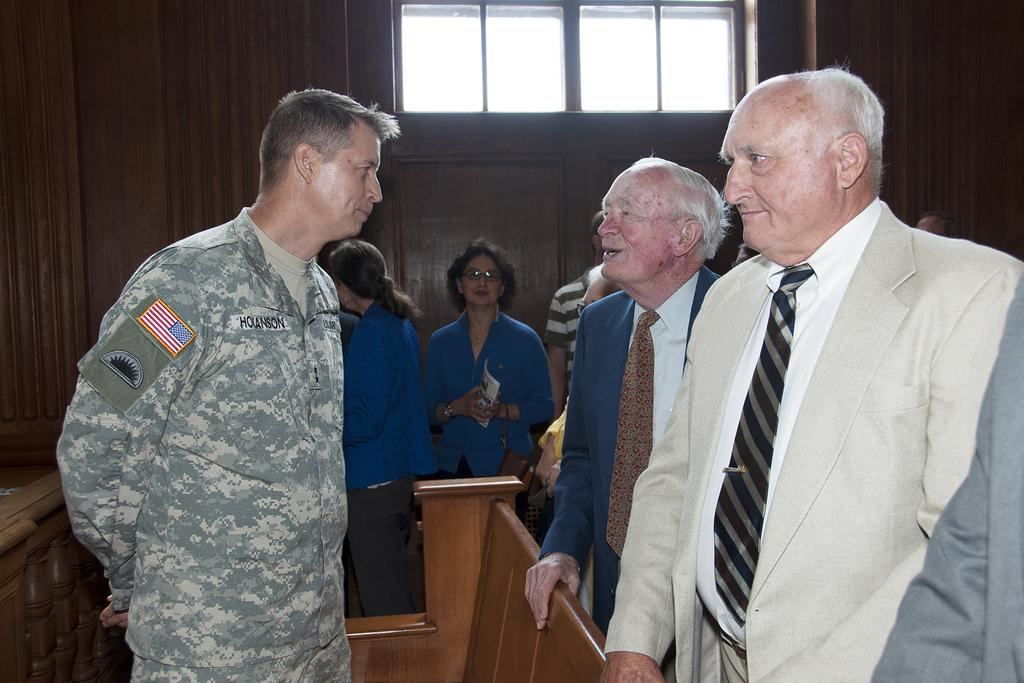How many people are in the room in the image? There is a group of people in the room, but the exact number cannot be determined from the image. What type of object made of wood can be seen in the room? There is a wooden object in the room, but its specific purpose or appearance cannot be determined from the image. Where is the window located in the room? There is a window in the middle of a wall in the room. What type of rice is being served in the room? There is no rice present in the image, so it cannot be determined what type of rice might be served. 